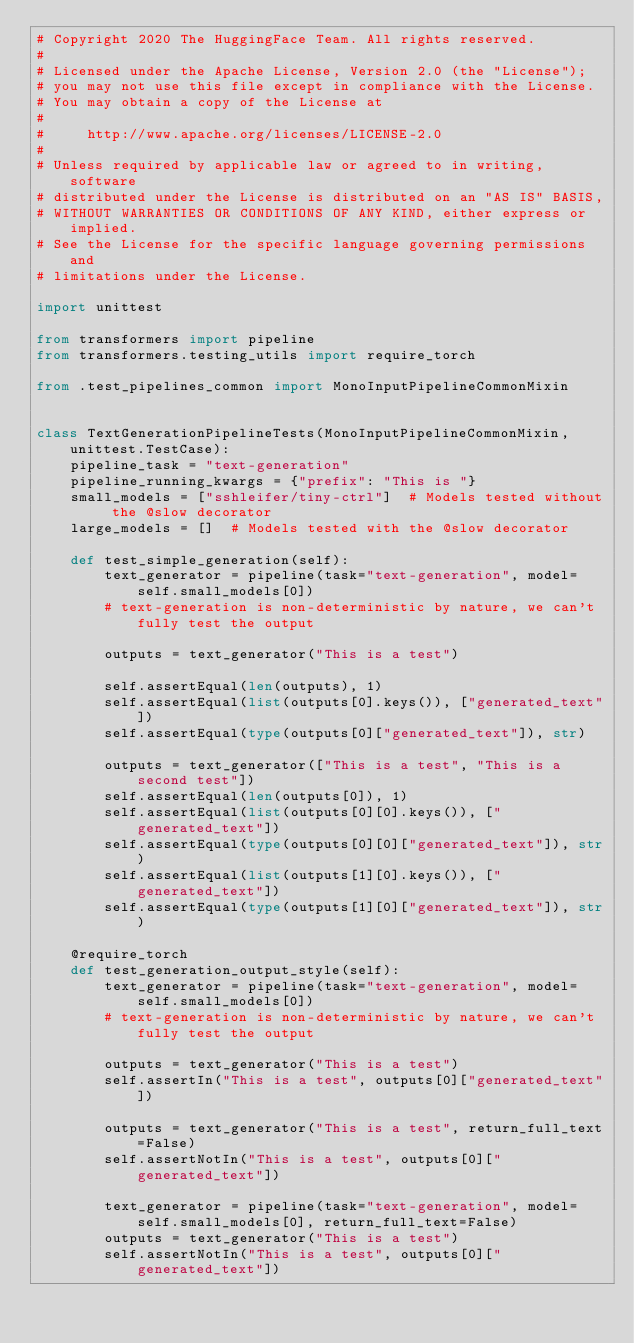Convert code to text. <code><loc_0><loc_0><loc_500><loc_500><_Python_># Copyright 2020 The HuggingFace Team. All rights reserved.
#
# Licensed under the Apache License, Version 2.0 (the "License");
# you may not use this file except in compliance with the License.
# You may obtain a copy of the License at
#
#     http://www.apache.org/licenses/LICENSE-2.0
#
# Unless required by applicable law or agreed to in writing, software
# distributed under the License is distributed on an "AS IS" BASIS,
# WITHOUT WARRANTIES OR CONDITIONS OF ANY KIND, either express or implied.
# See the License for the specific language governing permissions and
# limitations under the License.

import unittest

from transformers import pipeline
from transformers.testing_utils import require_torch

from .test_pipelines_common import MonoInputPipelineCommonMixin


class TextGenerationPipelineTests(MonoInputPipelineCommonMixin, unittest.TestCase):
    pipeline_task = "text-generation"
    pipeline_running_kwargs = {"prefix": "This is "}
    small_models = ["sshleifer/tiny-ctrl"]  # Models tested without the @slow decorator
    large_models = []  # Models tested with the @slow decorator

    def test_simple_generation(self):
        text_generator = pipeline(task="text-generation", model=self.small_models[0])
        # text-generation is non-deterministic by nature, we can't fully test the output

        outputs = text_generator("This is a test")

        self.assertEqual(len(outputs), 1)
        self.assertEqual(list(outputs[0].keys()), ["generated_text"])
        self.assertEqual(type(outputs[0]["generated_text"]), str)

        outputs = text_generator(["This is a test", "This is a second test"])
        self.assertEqual(len(outputs[0]), 1)
        self.assertEqual(list(outputs[0][0].keys()), ["generated_text"])
        self.assertEqual(type(outputs[0][0]["generated_text"]), str)
        self.assertEqual(list(outputs[1][0].keys()), ["generated_text"])
        self.assertEqual(type(outputs[1][0]["generated_text"]), str)

    @require_torch
    def test_generation_output_style(self):
        text_generator = pipeline(task="text-generation", model=self.small_models[0])
        # text-generation is non-deterministic by nature, we can't fully test the output

        outputs = text_generator("This is a test")
        self.assertIn("This is a test", outputs[0]["generated_text"])

        outputs = text_generator("This is a test", return_full_text=False)
        self.assertNotIn("This is a test", outputs[0]["generated_text"])

        text_generator = pipeline(task="text-generation", model=self.small_models[0], return_full_text=False)
        outputs = text_generator("This is a test")
        self.assertNotIn("This is a test", outputs[0]["generated_text"])
</code> 